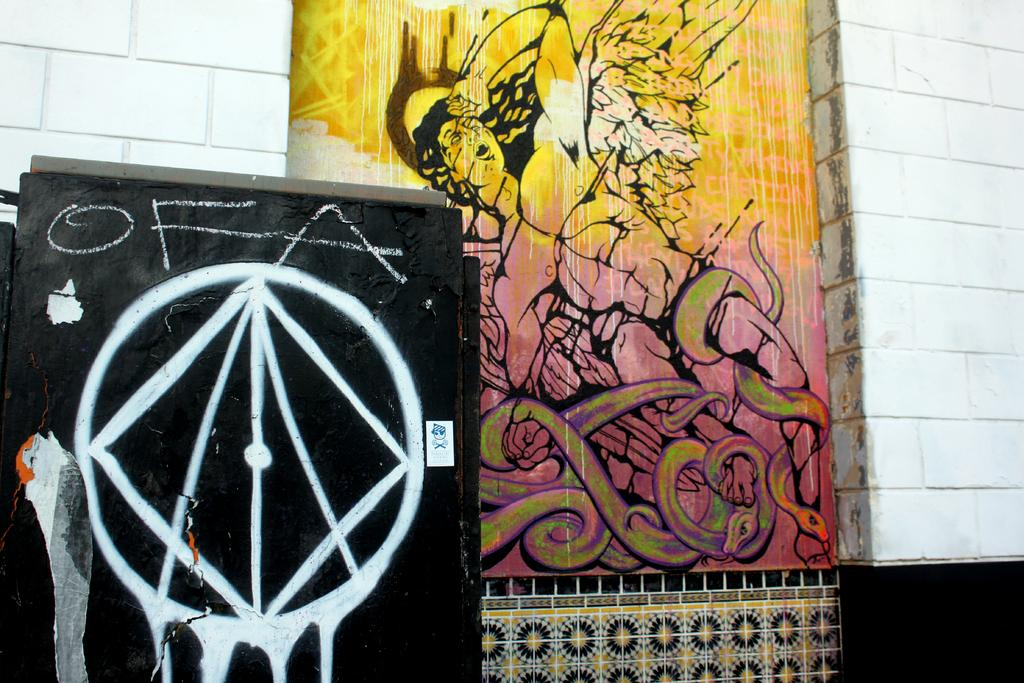What is depicted on the wall in the image? There are two paintings on the wall in the image. What is the color of the wall on which the paintings are hung? The wall is white in color. What type of hat is the doll wearing in the image? There is no doll or hat present in the image; it only features two paintings on a white wall. 